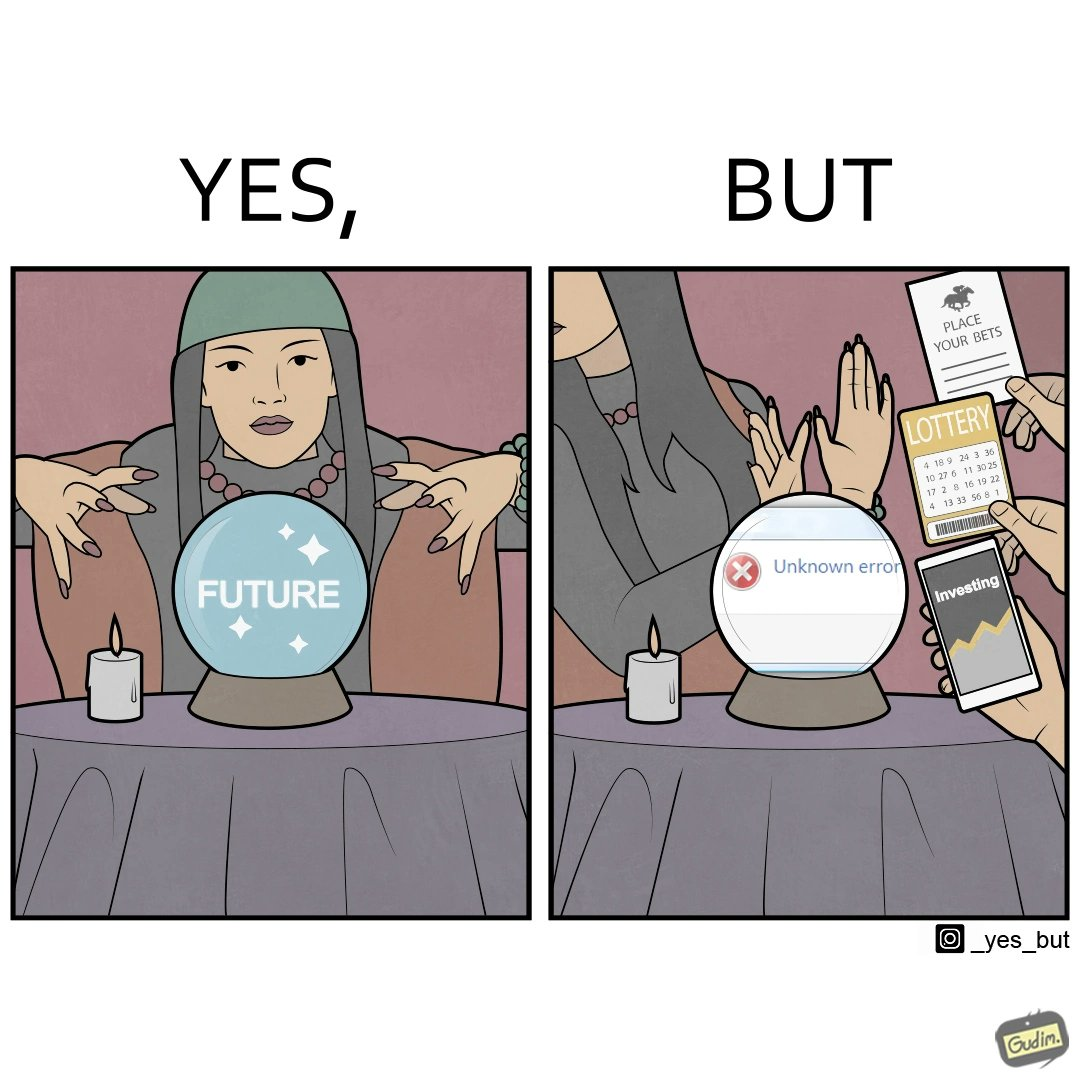What makes this image funny or satirical? The people who claim to predict the future either find their predictions unsuccessful or avoid themselves from making claims related to finance, lotteries, and bets. 